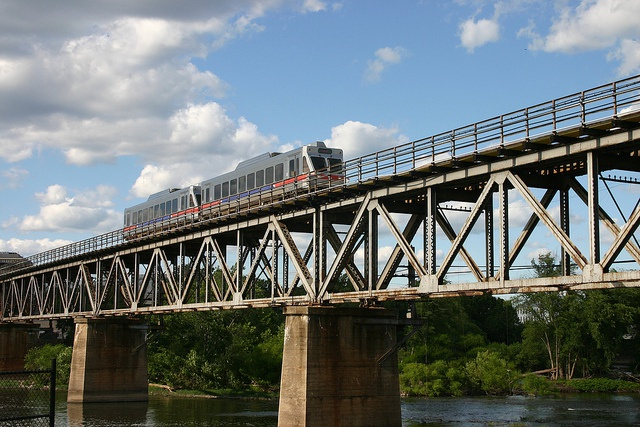Describe the objects in this image and their specific colors. I can see a train in darkgray, gray, and black tones in this image. 